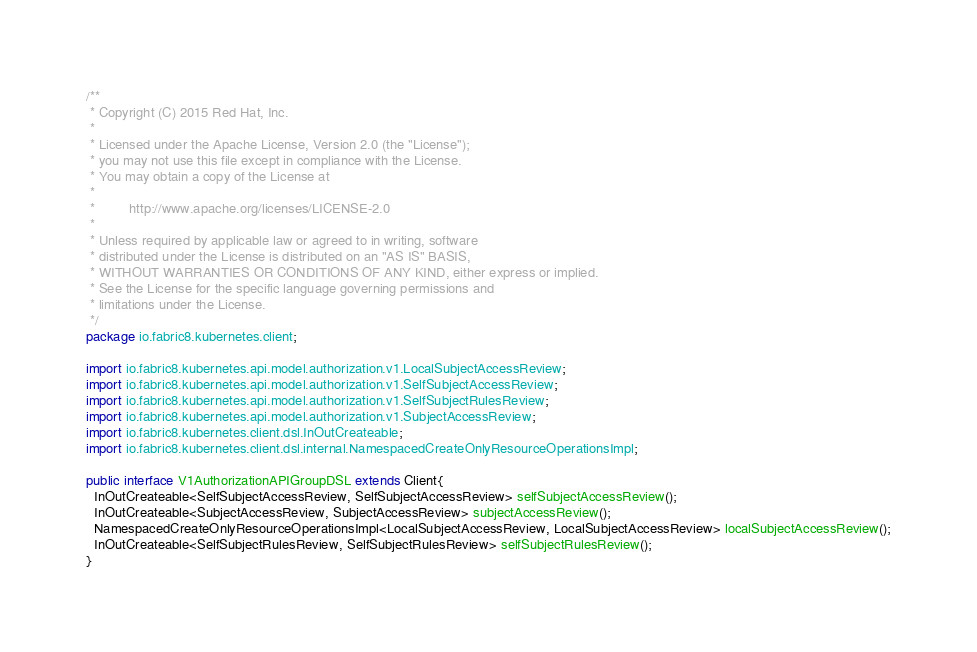<code> <loc_0><loc_0><loc_500><loc_500><_Java_>/**
 * Copyright (C) 2015 Red Hat, Inc.
 *
 * Licensed under the Apache License, Version 2.0 (the "License");
 * you may not use this file except in compliance with the License.
 * You may obtain a copy of the License at
 *
 *         http://www.apache.org/licenses/LICENSE-2.0
 *
 * Unless required by applicable law or agreed to in writing, software
 * distributed under the License is distributed on an "AS IS" BASIS,
 * WITHOUT WARRANTIES OR CONDITIONS OF ANY KIND, either express or implied.
 * See the License for the specific language governing permissions and
 * limitations under the License.
 */
package io.fabric8.kubernetes.client;

import io.fabric8.kubernetes.api.model.authorization.v1.LocalSubjectAccessReview;
import io.fabric8.kubernetes.api.model.authorization.v1.SelfSubjectAccessReview;
import io.fabric8.kubernetes.api.model.authorization.v1.SelfSubjectRulesReview;
import io.fabric8.kubernetes.api.model.authorization.v1.SubjectAccessReview;
import io.fabric8.kubernetes.client.dsl.InOutCreateable;
import io.fabric8.kubernetes.client.dsl.internal.NamespacedCreateOnlyResourceOperationsImpl;

public interface V1AuthorizationAPIGroupDSL extends Client{
  InOutCreateable<SelfSubjectAccessReview, SelfSubjectAccessReview> selfSubjectAccessReview();
  InOutCreateable<SubjectAccessReview, SubjectAccessReview> subjectAccessReview();
  NamespacedCreateOnlyResourceOperationsImpl<LocalSubjectAccessReview, LocalSubjectAccessReview> localSubjectAccessReview();
  InOutCreateable<SelfSubjectRulesReview, SelfSubjectRulesReview> selfSubjectRulesReview();
}
</code> 